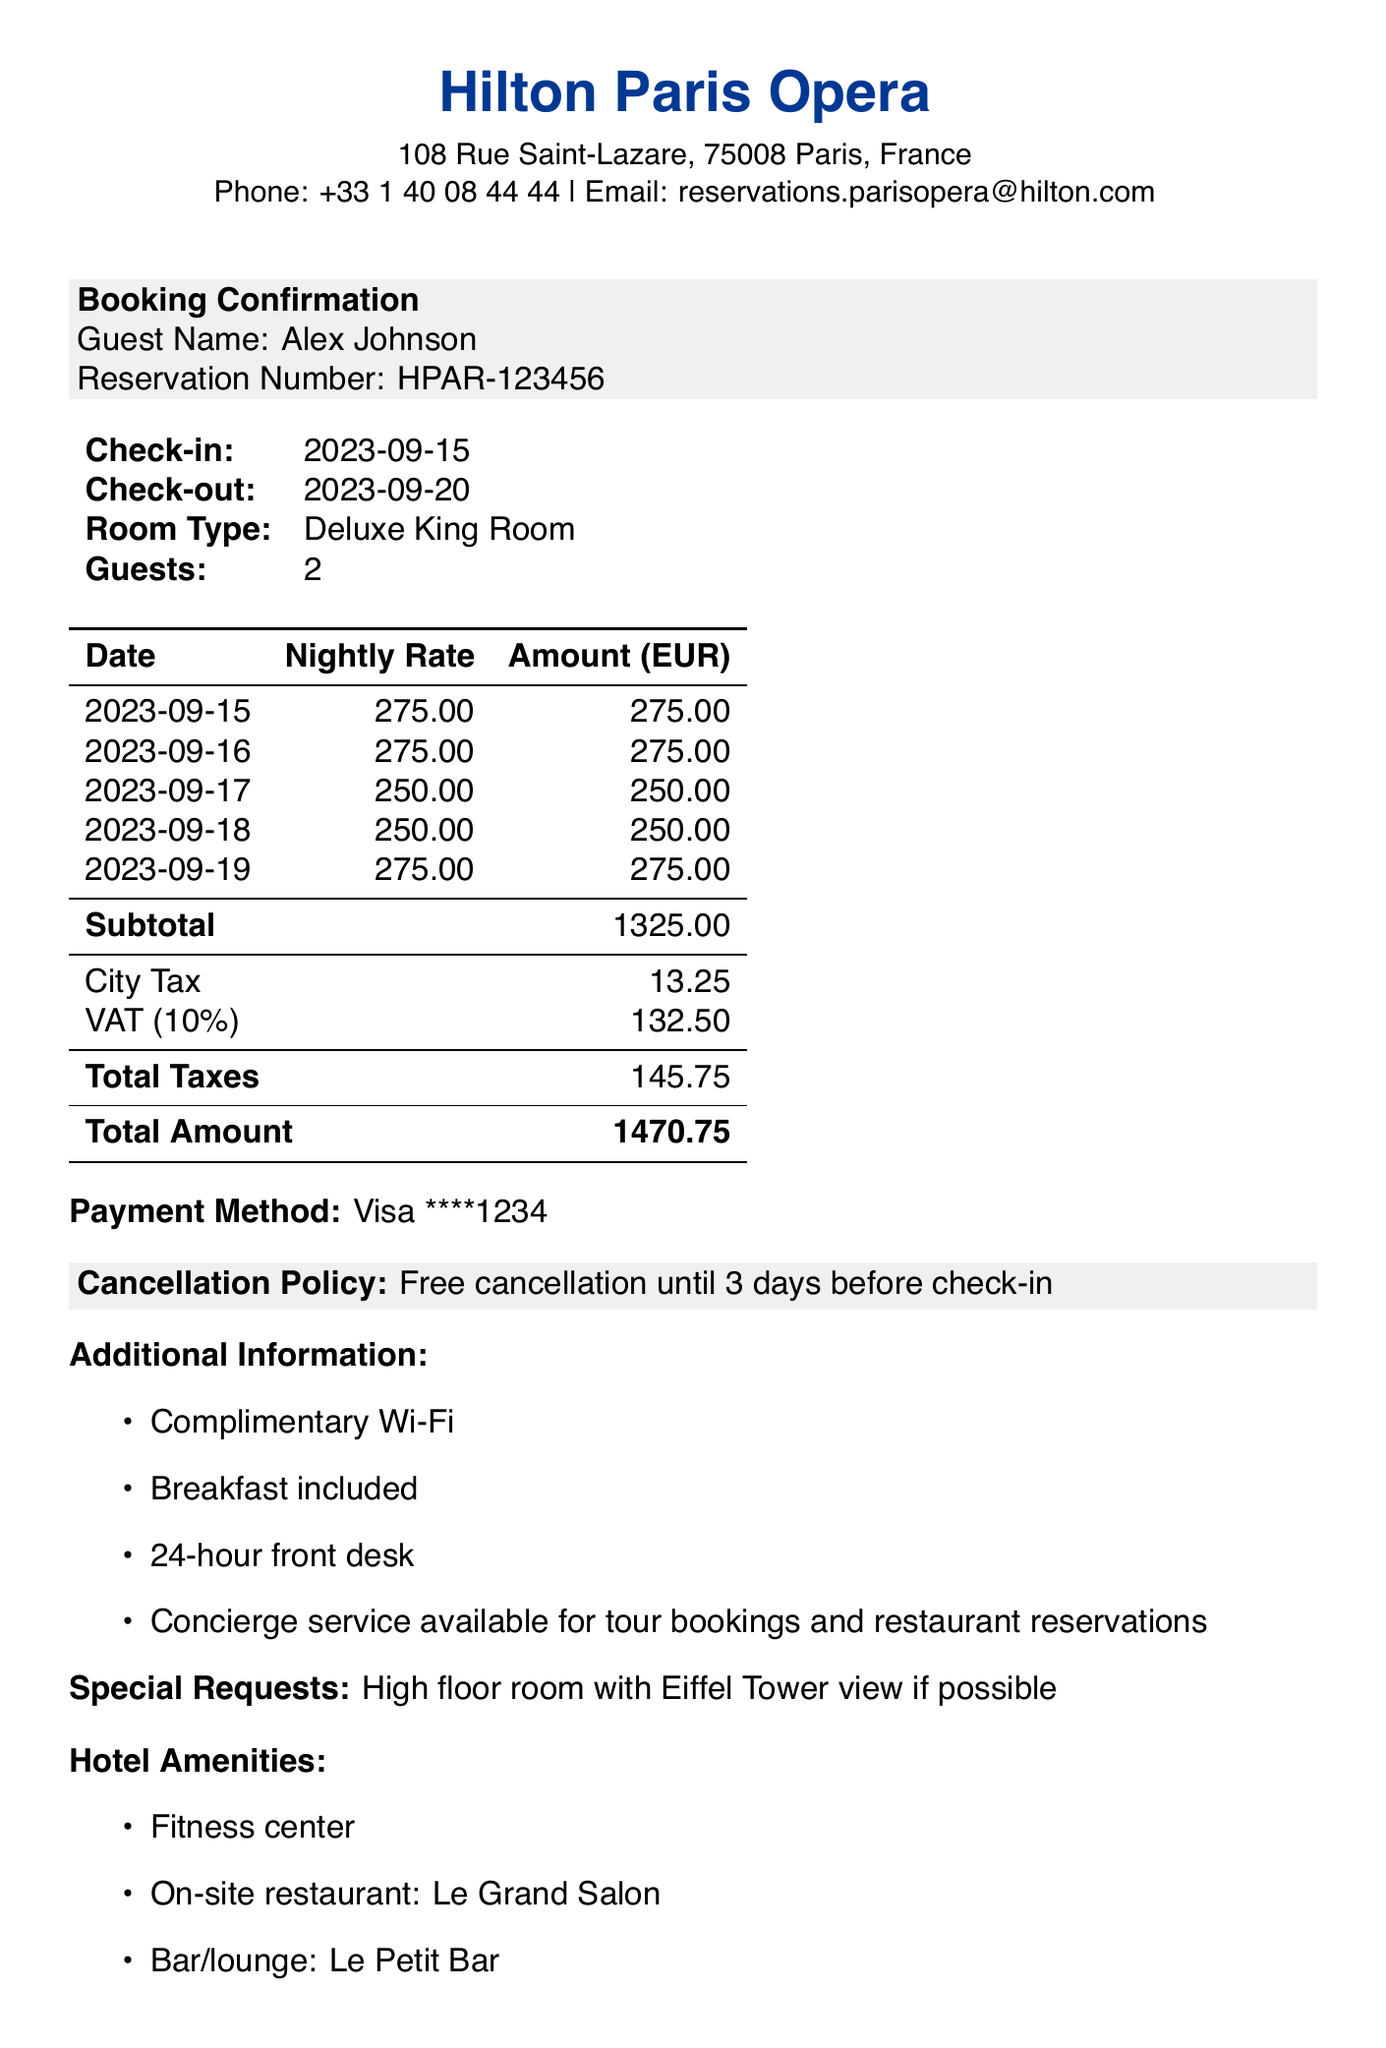What is the hotel name? The hotel name is explicitly stated in the document as the establishment where the booking was made.
Answer: Hilton Paris Opera What is the check-in date? The check-in date is provided in the reservation details section.
Answer: 2023-09-15 What is the subtotal before taxes? The subtotal is the total of all the nightly rates calculated before any taxes are added.
Answer: 1325.00 What is the total amount charged? The total amount includes the subtotal and all applicable taxes, as shown at the end of the receipt.
Answer: 1470.75 How many guests is the reservation for? The number of guests is listed in the details of the booking confirmation.
Answer: 2 What payment method was used? The payment method is specified towards the end of the document, detailing how the payment was made.
Answer: Visa ****1234 What is the cancellation policy? The cancellation policy is stated clearly to inform the guest of the conditions regarding changes to the reservation.
Answer: Free cancellation until 3 days before check-in Name one nearby attraction. The document provides a list of attractions near the hotel, which guests may find interesting.
Answer: Opéra Garnier What is included as additional information? This section lists various amenities and services that come with the booking, which enhances the guest experience.
Answer: Complimentary Wi-Fi What type of room was booked? The type of room is explicitly stated in the booking details section.
Answer: Deluxe King Room 